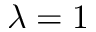<formula> <loc_0><loc_0><loc_500><loc_500>\lambda = 1</formula> 